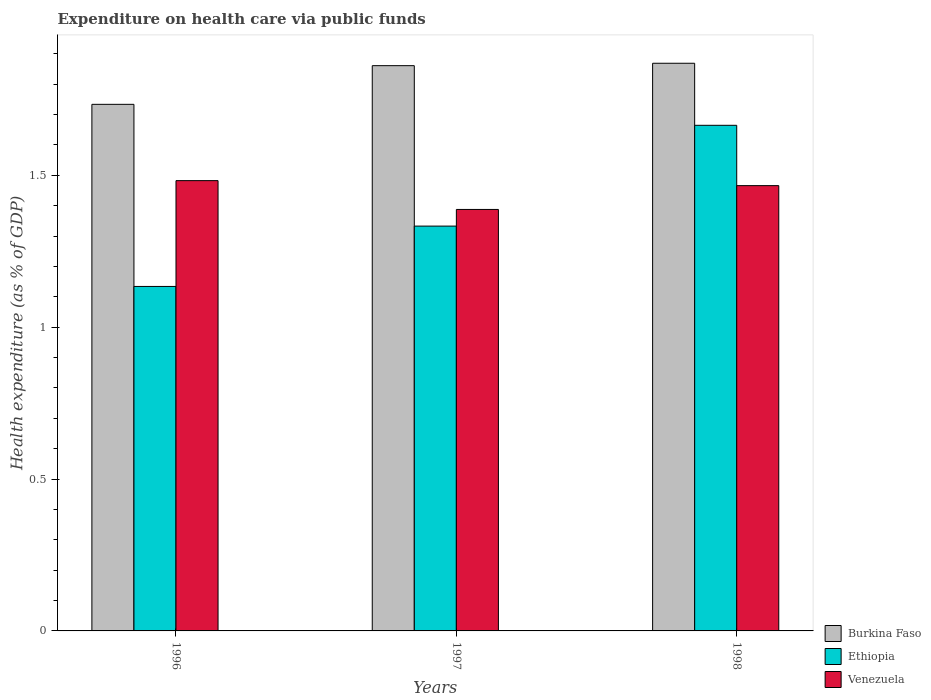How many different coloured bars are there?
Your answer should be very brief. 3. How many bars are there on the 2nd tick from the left?
Ensure brevity in your answer.  3. What is the label of the 1st group of bars from the left?
Your answer should be very brief. 1996. What is the expenditure made on health care in Ethiopia in 1998?
Offer a terse response. 1.66. Across all years, what is the maximum expenditure made on health care in Burkina Faso?
Give a very brief answer. 1.87. Across all years, what is the minimum expenditure made on health care in Ethiopia?
Make the answer very short. 1.13. In which year was the expenditure made on health care in Venezuela maximum?
Provide a succinct answer. 1996. In which year was the expenditure made on health care in Burkina Faso minimum?
Offer a terse response. 1996. What is the total expenditure made on health care in Ethiopia in the graph?
Keep it short and to the point. 4.13. What is the difference between the expenditure made on health care in Venezuela in 1997 and that in 1998?
Provide a short and direct response. -0.08. What is the difference between the expenditure made on health care in Venezuela in 1998 and the expenditure made on health care in Ethiopia in 1997?
Keep it short and to the point. 0.13. What is the average expenditure made on health care in Venezuela per year?
Provide a short and direct response. 1.45. In the year 1996, what is the difference between the expenditure made on health care in Ethiopia and expenditure made on health care in Venezuela?
Give a very brief answer. -0.35. What is the ratio of the expenditure made on health care in Ethiopia in 1997 to that in 1998?
Provide a succinct answer. 0.8. What is the difference between the highest and the second highest expenditure made on health care in Venezuela?
Offer a very short reply. 0.02. What is the difference between the highest and the lowest expenditure made on health care in Venezuela?
Provide a short and direct response. 0.09. Is the sum of the expenditure made on health care in Burkina Faso in 1996 and 1998 greater than the maximum expenditure made on health care in Ethiopia across all years?
Provide a succinct answer. Yes. What does the 2nd bar from the left in 1998 represents?
Offer a terse response. Ethiopia. What does the 1st bar from the right in 1996 represents?
Offer a very short reply. Venezuela. How many bars are there?
Offer a very short reply. 9. Are all the bars in the graph horizontal?
Your response must be concise. No. Does the graph contain grids?
Give a very brief answer. No. Where does the legend appear in the graph?
Make the answer very short. Bottom right. What is the title of the graph?
Make the answer very short. Expenditure on health care via public funds. What is the label or title of the X-axis?
Offer a terse response. Years. What is the label or title of the Y-axis?
Provide a succinct answer. Health expenditure (as % of GDP). What is the Health expenditure (as % of GDP) of Burkina Faso in 1996?
Offer a terse response. 1.73. What is the Health expenditure (as % of GDP) in Ethiopia in 1996?
Provide a succinct answer. 1.13. What is the Health expenditure (as % of GDP) of Venezuela in 1996?
Ensure brevity in your answer.  1.48. What is the Health expenditure (as % of GDP) of Burkina Faso in 1997?
Give a very brief answer. 1.86. What is the Health expenditure (as % of GDP) of Ethiopia in 1997?
Provide a short and direct response. 1.33. What is the Health expenditure (as % of GDP) of Venezuela in 1997?
Your answer should be very brief. 1.39. What is the Health expenditure (as % of GDP) of Burkina Faso in 1998?
Ensure brevity in your answer.  1.87. What is the Health expenditure (as % of GDP) of Ethiopia in 1998?
Your answer should be very brief. 1.66. What is the Health expenditure (as % of GDP) in Venezuela in 1998?
Ensure brevity in your answer.  1.47. Across all years, what is the maximum Health expenditure (as % of GDP) in Burkina Faso?
Your answer should be very brief. 1.87. Across all years, what is the maximum Health expenditure (as % of GDP) in Ethiopia?
Your answer should be very brief. 1.66. Across all years, what is the maximum Health expenditure (as % of GDP) in Venezuela?
Offer a terse response. 1.48. Across all years, what is the minimum Health expenditure (as % of GDP) of Burkina Faso?
Offer a terse response. 1.73. Across all years, what is the minimum Health expenditure (as % of GDP) in Ethiopia?
Offer a terse response. 1.13. Across all years, what is the minimum Health expenditure (as % of GDP) in Venezuela?
Offer a very short reply. 1.39. What is the total Health expenditure (as % of GDP) of Burkina Faso in the graph?
Ensure brevity in your answer.  5.46. What is the total Health expenditure (as % of GDP) of Ethiopia in the graph?
Keep it short and to the point. 4.13. What is the total Health expenditure (as % of GDP) of Venezuela in the graph?
Keep it short and to the point. 4.34. What is the difference between the Health expenditure (as % of GDP) in Burkina Faso in 1996 and that in 1997?
Offer a very short reply. -0.13. What is the difference between the Health expenditure (as % of GDP) of Ethiopia in 1996 and that in 1997?
Make the answer very short. -0.2. What is the difference between the Health expenditure (as % of GDP) in Venezuela in 1996 and that in 1997?
Offer a terse response. 0.09. What is the difference between the Health expenditure (as % of GDP) in Burkina Faso in 1996 and that in 1998?
Your answer should be very brief. -0.14. What is the difference between the Health expenditure (as % of GDP) in Ethiopia in 1996 and that in 1998?
Give a very brief answer. -0.53. What is the difference between the Health expenditure (as % of GDP) in Venezuela in 1996 and that in 1998?
Offer a very short reply. 0.02. What is the difference between the Health expenditure (as % of GDP) in Burkina Faso in 1997 and that in 1998?
Provide a short and direct response. -0.01. What is the difference between the Health expenditure (as % of GDP) of Ethiopia in 1997 and that in 1998?
Give a very brief answer. -0.33. What is the difference between the Health expenditure (as % of GDP) of Venezuela in 1997 and that in 1998?
Give a very brief answer. -0.08. What is the difference between the Health expenditure (as % of GDP) of Burkina Faso in 1996 and the Health expenditure (as % of GDP) of Ethiopia in 1997?
Your response must be concise. 0.4. What is the difference between the Health expenditure (as % of GDP) of Burkina Faso in 1996 and the Health expenditure (as % of GDP) of Venezuela in 1997?
Provide a succinct answer. 0.35. What is the difference between the Health expenditure (as % of GDP) in Ethiopia in 1996 and the Health expenditure (as % of GDP) in Venezuela in 1997?
Provide a short and direct response. -0.25. What is the difference between the Health expenditure (as % of GDP) in Burkina Faso in 1996 and the Health expenditure (as % of GDP) in Ethiopia in 1998?
Keep it short and to the point. 0.07. What is the difference between the Health expenditure (as % of GDP) in Burkina Faso in 1996 and the Health expenditure (as % of GDP) in Venezuela in 1998?
Offer a very short reply. 0.27. What is the difference between the Health expenditure (as % of GDP) of Ethiopia in 1996 and the Health expenditure (as % of GDP) of Venezuela in 1998?
Give a very brief answer. -0.33. What is the difference between the Health expenditure (as % of GDP) in Burkina Faso in 1997 and the Health expenditure (as % of GDP) in Ethiopia in 1998?
Your answer should be compact. 0.2. What is the difference between the Health expenditure (as % of GDP) in Burkina Faso in 1997 and the Health expenditure (as % of GDP) in Venezuela in 1998?
Ensure brevity in your answer.  0.39. What is the difference between the Health expenditure (as % of GDP) in Ethiopia in 1997 and the Health expenditure (as % of GDP) in Venezuela in 1998?
Offer a very short reply. -0.13. What is the average Health expenditure (as % of GDP) of Burkina Faso per year?
Offer a very short reply. 1.82. What is the average Health expenditure (as % of GDP) of Ethiopia per year?
Your response must be concise. 1.38. What is the average Health expenditure (as % of GDP) in Venezuela per year?
Your response must be concise. 1.45. In the year 1996, what is the difference between the Health expenditure (as % of GDP) in Burkina Faso and Health expenditure (as % of GDP) in Ethiopia?
Your response must be concise. 0.6. In the year 1996, what is the difference between the Health expenditure (as % of GDP) in Burkina Faso and Health expenditure (as % of GDP) in Venezuela?
Your response must be concise. 0.25. In the year 1996, what is the difference between the Health expenditure (as % of GDP) of Ethiopia and Health expenditure (as % of GDP) of Venezuela?
Provide a short and direct response. -0.35. In the year 1997, what is the difference between the Health expenditure (as % of GDP) of Burkina Faso and Health expenditure (as % of GDP) of Ethiopia?
Your answer should be compact. 0.53. In the year 1997, what is the difference between the Health expenditure (as % of GDP) in Burkina Faso and Health expenditure (as % of GDP) in Venezuela?
Your answer should be very brief. 0.47. In the year 1997, what is the difference between the Health expenditure (as % of GDP) of Ethiopia and Health expenditure (as % of GDP) of Venezuela?
Keep it short and to the point. -0.05. In the year 1998, what is the difference between the Health expenditure (as % of GDP) of Burkina Faso and Health expenditure (as % of GDP) of Ethiopia?
Offer a very short reply. 0.2. In the year 1998, what is the difference between the Health expenditure (as % of GDP) of Burkina Faso and Health expenditure (as % of GDP) of Venezuela?
Your answer should be compact. 0.4. In the year 1998, what is the difference between the Health expenditure (as % of GDP) in Ethiopia and Health expenditure (as % of GDP) in Venezuela?
Your response must be concise. 0.2. What is the ratio of the Health expenditure (as % of GDP) in Burkina Faso in 1996 to that in 1997?
Make the answer very short. 0.93. What is the ratio of the Health expenditure (as % of GDP) in Ethiopia in 1996 to that in 1997?
Provide a succinct answer. 0.85. What is the ratio of the Health expenditure (as % of GDP) of Venezuela in 1996 to that in 1997?
Your answer should be compact. 1.07. What is the ratio of the Health expenditure (as % of GDP) of Burkina Faso in 1996 to that in 1998?
Ensure brevity in your answer.  0.93. What is the ratio of the Health expenditure (as % of GDP) in Ethiopia in 1996 to that in 1998?
Your answer should be compact. 0.68. What is the ratio of the Health expenditure (as % of GDP) of Venezuela in 1996 to that in 1998?
Your answer should be very brief. 1.01. What is the ratio of the Health expenditure (as % of GDP) in Burkina Faso in 1997 to that in 1998?
Keep it short and to the point. 1. What is the ratio of the Health expenditure (as % of GDP) in Ethiopia in 1997 to that in 1998?
Give a very brief answer. 0.8. What is the ratio of the Health expenditure (as % of GDP) in Venezuela in 1997 to that in 1998?
Offer a very short reply. 0.95. What is the difference between the highest and the second highest Health expenditure (as % of GDP) in Burkina Faso?
Your answer should be compact. 0.01. What is the difference between the highest and the second highest Health expenditure (as % of GDP) of Ethiopia?
Your answer should be very brief. 0.33. What is the difference between the highest and the second highest Health expenditure (as % of GDP) in Venezuela?
Make the answer very short. 0.02. What is the difference between the highest and the lowest Health expenditure (as % of GDP) of Burkina Faso?
Provide a short and direct response. 0.14. What is the difference between the highest and the lowest Health expenditure (as % of GDP) in Ethiopia?
Give a very brief answer. 0.53. What is the difference between the highest and the lowest Health expenditure (as % of GDP) of Venezuela?
Keep it short and to the point. 0.09. 